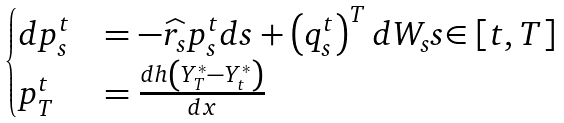Convert formula to latex. <formula><loc_0><loc_0><loc_500><loc_500>\begin{cases} d p _ { s } ^ { t } & = - \widehat { r _ { s } } p _ { s } ^ { t } d s + \left ( q _ { s } ^ { t } \right ) ^ { T } d W _ { s } s { \in \left [ t , T \right ] } \\ p _ { T } ^ { t } & = \frac { d h \left ( Y _ { T } ^ { * } - Y _ { t } ^ { * } \right ) } { d x } \end{cases}</formula> 